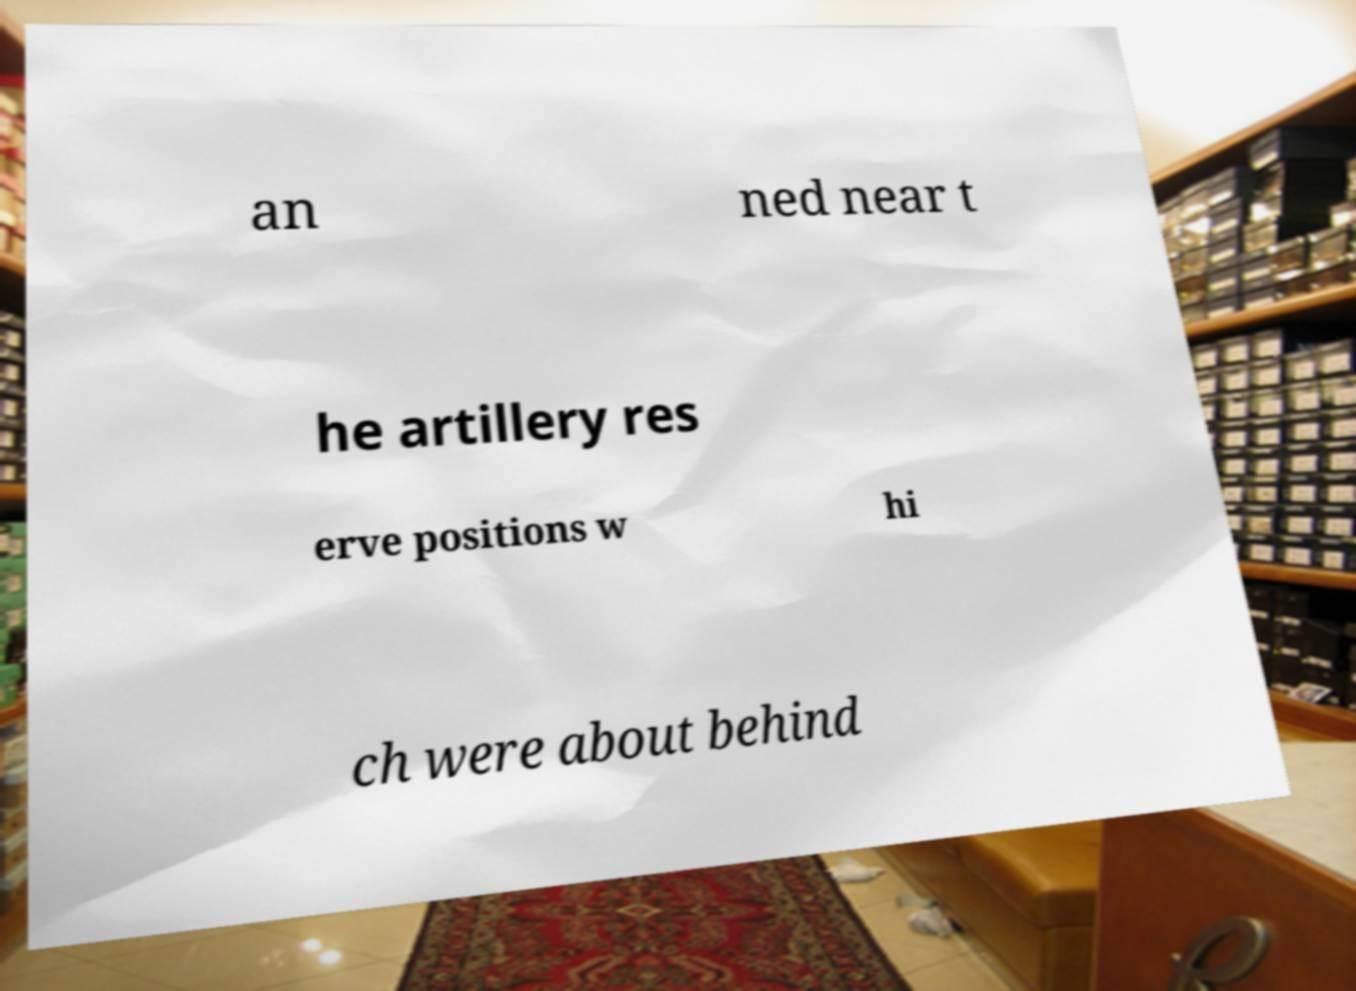Could you assist in decoding the text presented in this image and type it out clearly? an ned near t he artillery res erve positions w hi ch were about behind 